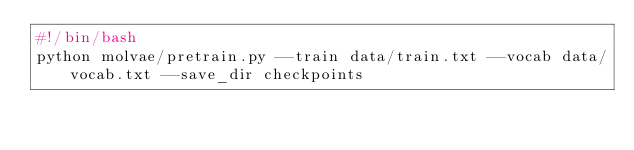Convert code to text. <code><loc_0><loc_0><loc_500><loc_500><_Bash_>#!/bin/bash
python molvae/pretrain.py --train data/train.txt --vocab data/vocab.txt --save_dir checkpoints
</code> 